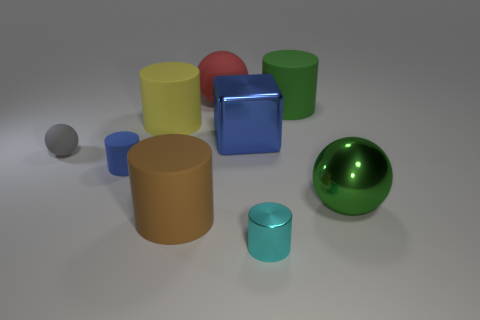Subtract all red rubber balls. How many balls are left? 2 Subtract 1 balls. How many balls are left? 2 Add 1 large brown spheres. How many objects exist? 10 Subtract all small red objects. Subtract all small cylinders. How many objects are left? 7 Add 9 cubes. How many cubes are left? 10 Add 8 tiny balls. How many tiny balls exist? 9 Subtract all yellow cylinders. How many cylinders are left? 4 Subtract 1 cyan cylinders. How many objects are left? 8 Subtract all cubes. How many objects are left? 8 Subtract all red cylinders. Subtract all gray cubes. How many cylinders are left? 5 